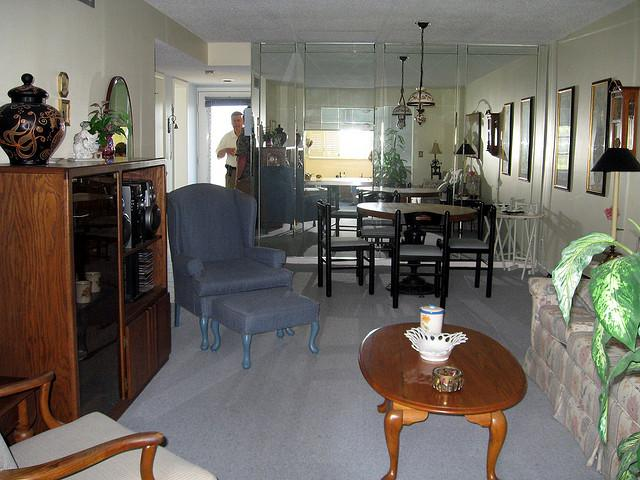What color is the vase in the middle of the coffee table? Please explain your reasoning. white. There is a white vase in the middle of the table. 